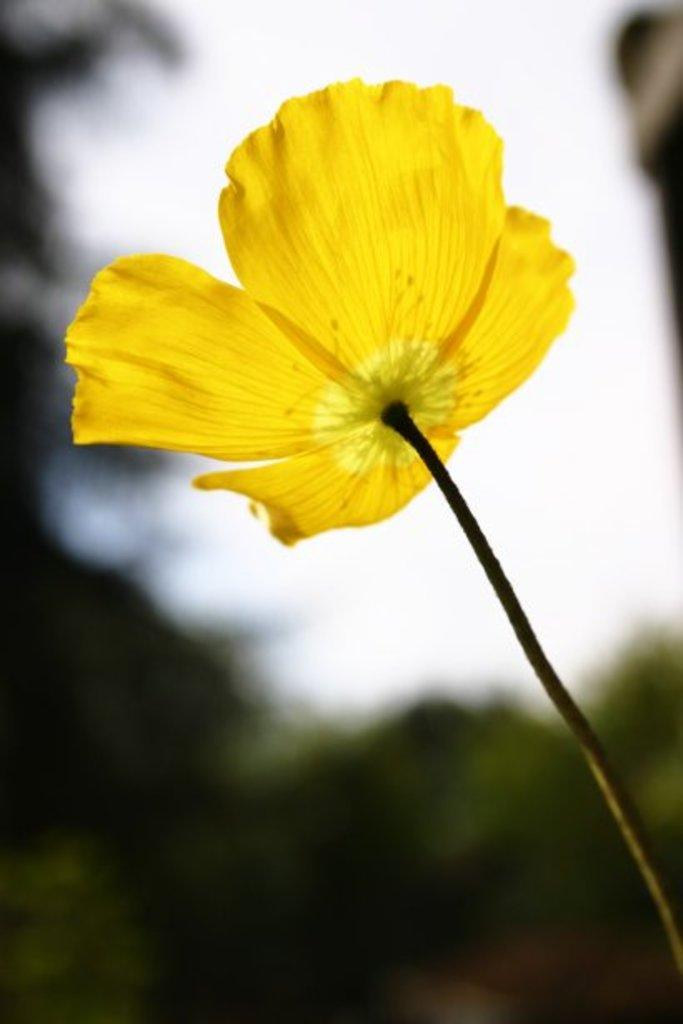What is the main subject of the image? There is a flower in the image. What color is the flower? The flower is yellow. Can you describe the background of the image? The background of the image is blurry. What type of business does the flower represent in the image? The image does not depict a business or any representation of a business. The image only features a yellow flower with a blurry background. 